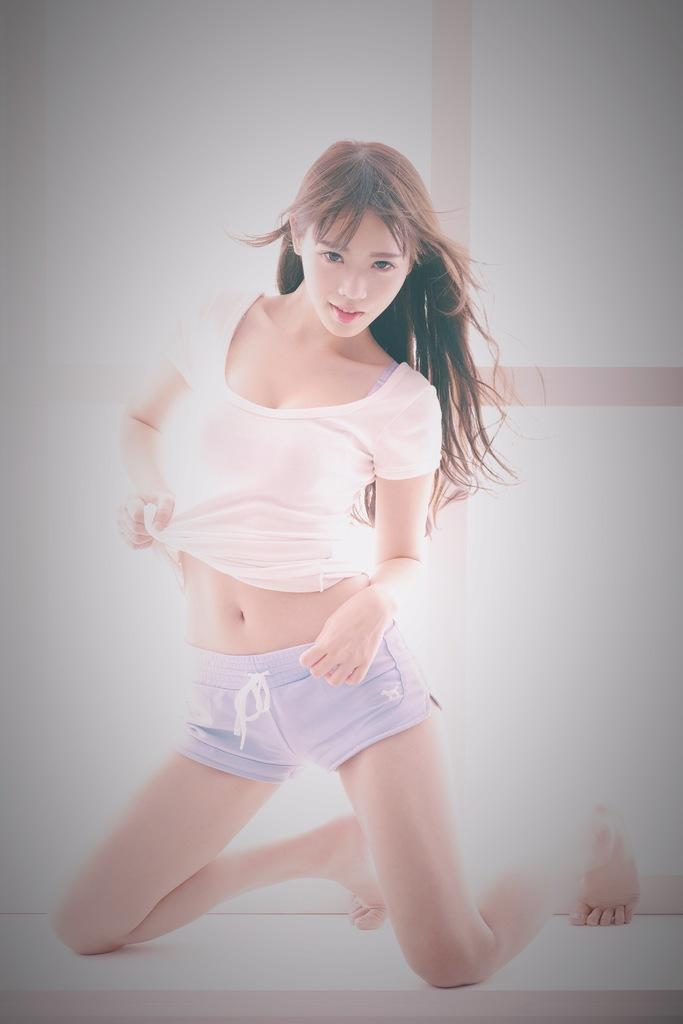Who is the main subject in the picture? There is a woman in the picture. What is the woman wearing? The woman is wearing a white and blue dress. What is the woman doing in the picture? The woman is posing for the photo. Has the image been altered in any way? Yes, the image has been edited. What type of bait is the woman using in the picture? There is no bait present in the image; the woman is wearing a white and blue dress and posing for a photo. Can you describe the bedroom where the woman is standing in the picture? There is no bedroom visible in the image; it only shows the woman posing for a photo. 